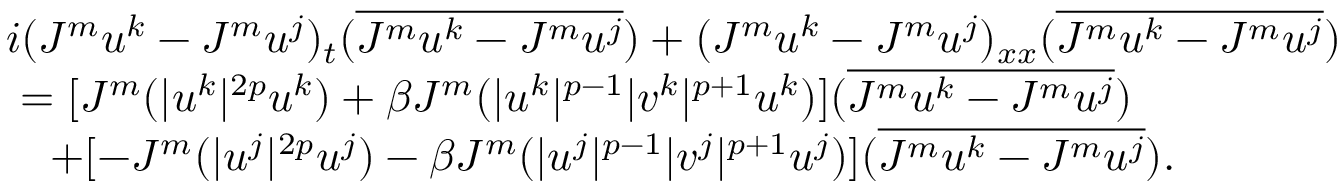<formula> <loc_0><loc_0><loc_500><loc_500>\begin{array} { r l } & { i ( J ^ { m } u ^ { k } - J ^ { m } u ^ { j } ) _ { t } ( \overline { { J ^ { m } u ^ { k } - J ^ { m } u ^ { j } } } ) + ( J ^ { m } u ^ { k } - J ^ { m } u ^ { j } ) _ { x x } ( \overline { { J ^ { m } u ^ { k } - J ^ { m } u ^ { j } } } ) } \\ & { \ = [ J ^ { m } ( | u ^ { k } | ^ { 2 p } u ^ { k } ) + \beta J ^ { m } ( | u ^ { k } | ^ { p - 1 } | v ^ { k } | ^ { p + 1 } u ^ { k } ) ] ( \overline { { J ^ { m } u ^ { k } - J ^ { m } u ^ { j } } } ) } \\ & { \quad + [ - J ^ { m } ( | u ^ { j } | ^ { 2 p } u ^ { j } ) - \beta J ^ { m } ( | u ^ { j } | ^ { p - 1 } | v ^ { j } | ^ { p + 1 } u ^ { j } ) ] ( \overline { { J ^ { m } u ^ { k } - J ^ { m } u ^ { j } } } ) . } \end{array}</formula> 